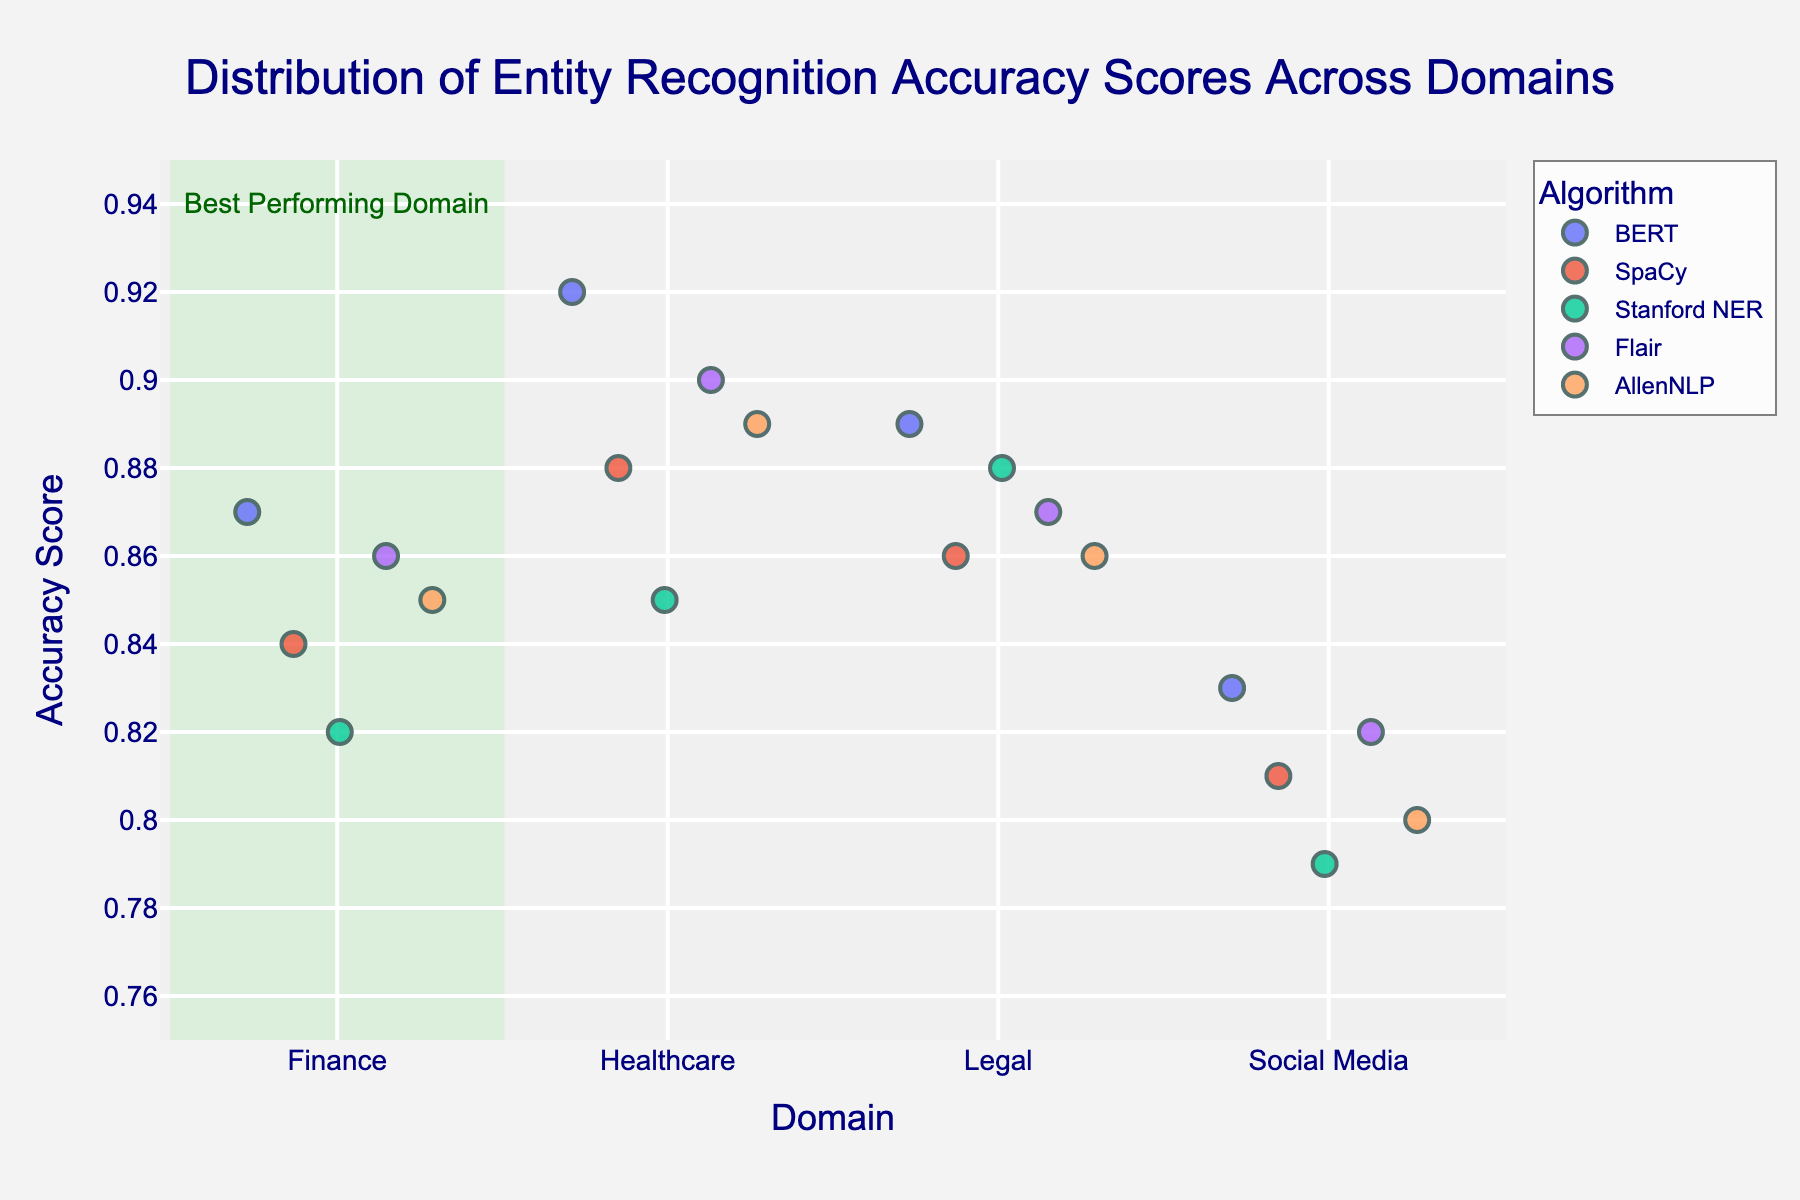What's the title of the plot? The title of the plot is displayed prominently at the top.
Answer: Distribution of Entity Recognition Accuracy Scores Across Domains What are the x-axis and y-axis labels on the plot? The x-axis label is shown along the horizontal axis and the y-axis label is along the vertical axis.
Answer: Domain, Accuracy Score Which domain has the highest recorded accuracy score, and what is it? By visually inspecting the data points, we observe that the highest accuracy score is in the Healthcare domain. Checking the y-axis, the score is 0.92.
Answer: Healthcare, 0.92 How many parsing algorithms have been compared in the plot? Different colors represent different parsing algorithms. Counting the distinct colors and referencing the legend, we find five algorithms represented.
Answer: Five Which parsing algorithm has the lowest accuracy score in the Social Media domain? We look at the data points for the Social Media domain and identify the lowest accuracy score. This point, colored uniquely for each algorithm in the legend, belongs to Stanford NER.
Answer: Stanford NER What is the average accuracy score for the BERT algorithm across all domains? To find this, we add the accuracy scores for BERT in all domains (0.87+0.92+0.89+0.83) and divide by the number of domains (4). The result is (0.87 + 0.92 + 0.89 + 0.83) / 4 = 3.51 / 4 = 0.88.
Answer: 0.88 Which domain has the highest number of points above 0.85 accuracy? For each domain, count the data points above 0.85 accuracy by examining the vertical distribution on the y-axis. Healthcare has four points above 0.85.
Answer: Healthcare What's the range of accuracy scores for the AllenNLP algorithm in the Legal domain? For AllenNLP in the Legal domain, we locate the data point in the plot and read its y-value, which is consistent across the visual representation.
Answer: 0.86 How does Flair perform in the Finance domain compared to SpaCy in the same domain? We compare the accuracy scores of Flair and SpaCy in the Finance domain. Flair has 0.86, while SpaCy has 0.84. Flair performs slightly better.
Answer: Flair is higher by 0.02 Which domain is highlighted as the best performing and why? By identifying the rectangular highlight and the associated annotation, the Healthcare domain is indicated as the best performing, based on higher accuracy scores.
Answer: Healthcare, due to highest scores 